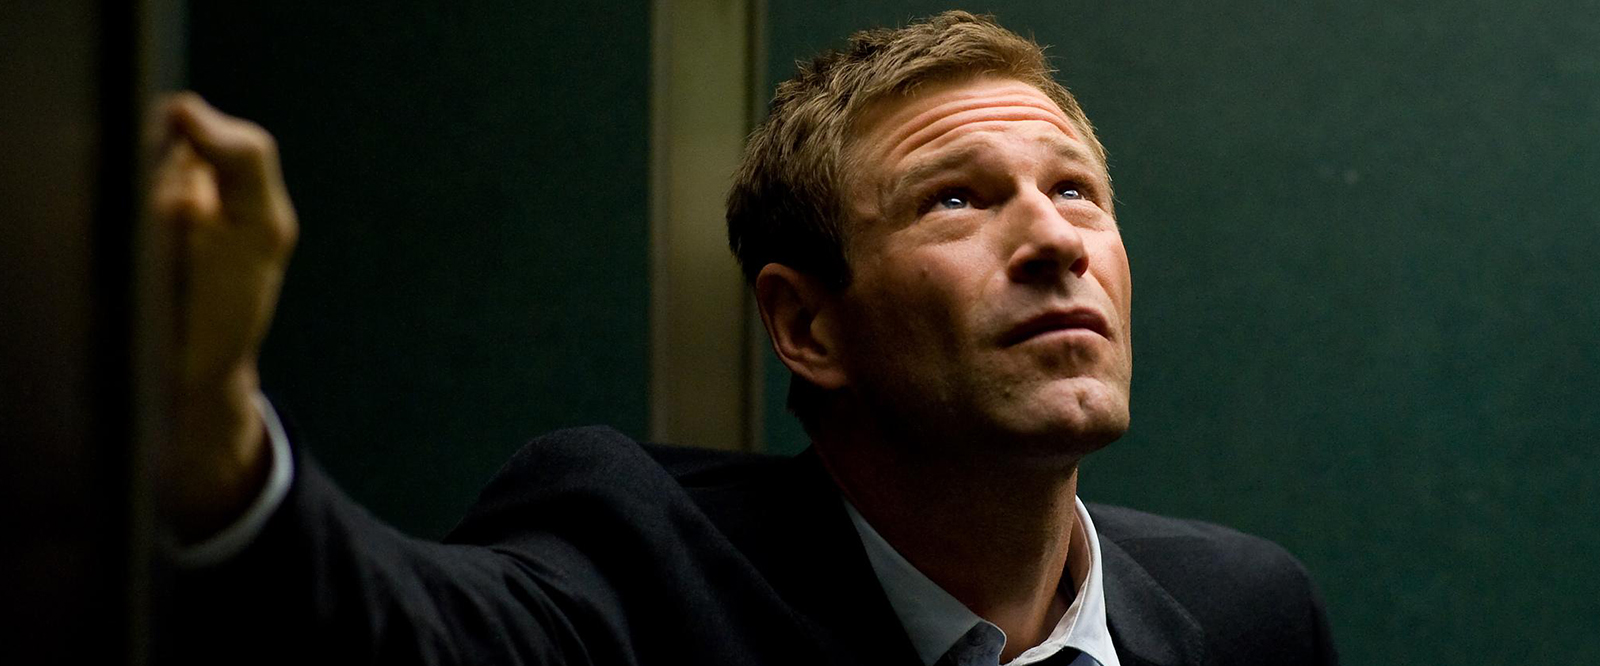What might this character be contemplating in this dramatic setting? The character appears to be deeply immersed in thought or possibly watching an event unfolding off-camera. His furrowed brows and intense look upwards suggest he might be worried or anxious about a situation that requires serious contemplation or immediate decisions. 